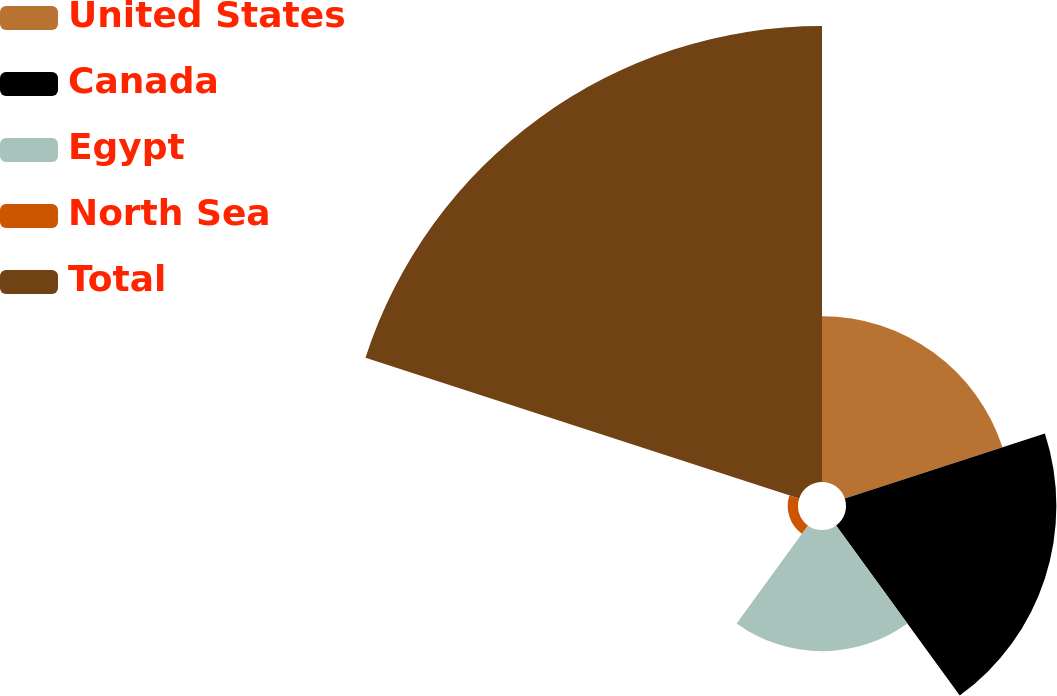<chart> <loc_0><loc_0><loc_500><loc_500><pie_chart><fcel>United States<fcel>Canada<fcel>Egypt<fcel>North Sea<fcel>Total<nl><fcel>17.2%<fcel>21.83%<fcel>12.58%<fcel>1.07%<fcel>47.32%<nl></chart> 